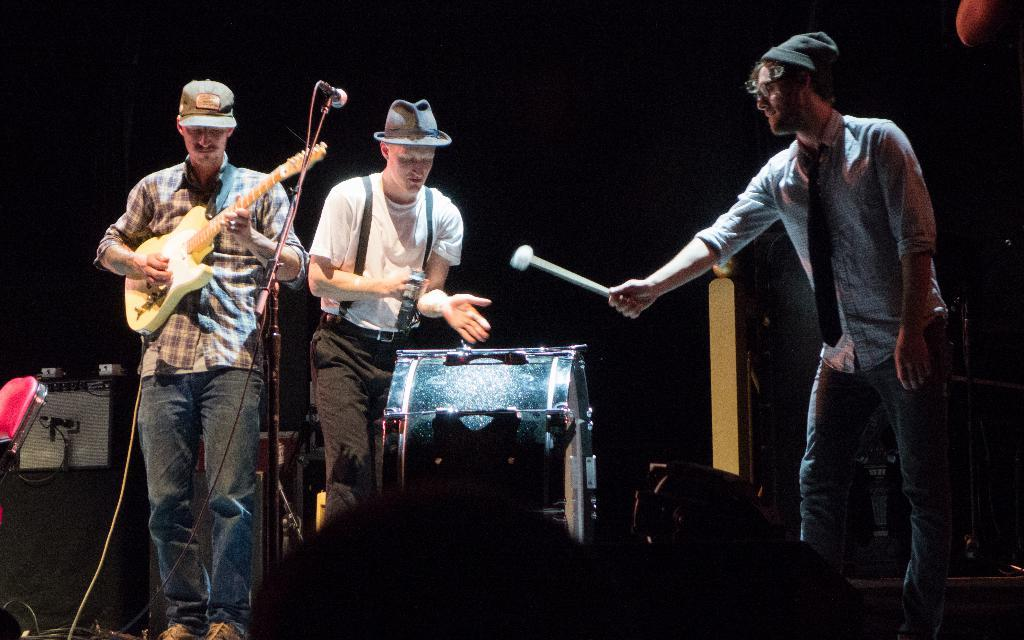How many people are on the stage in the image? There are 3 people on the stage in the image. What are the people on the stage doing? The people are performing. What type of performance is taking place? The performance involves playing musical instruments. What type of rod is being used by the dad to iron the linen in the image? There is no dad, rod, or linen present in the image. The image features 3 people performing by playing musical instruments on a stage. 